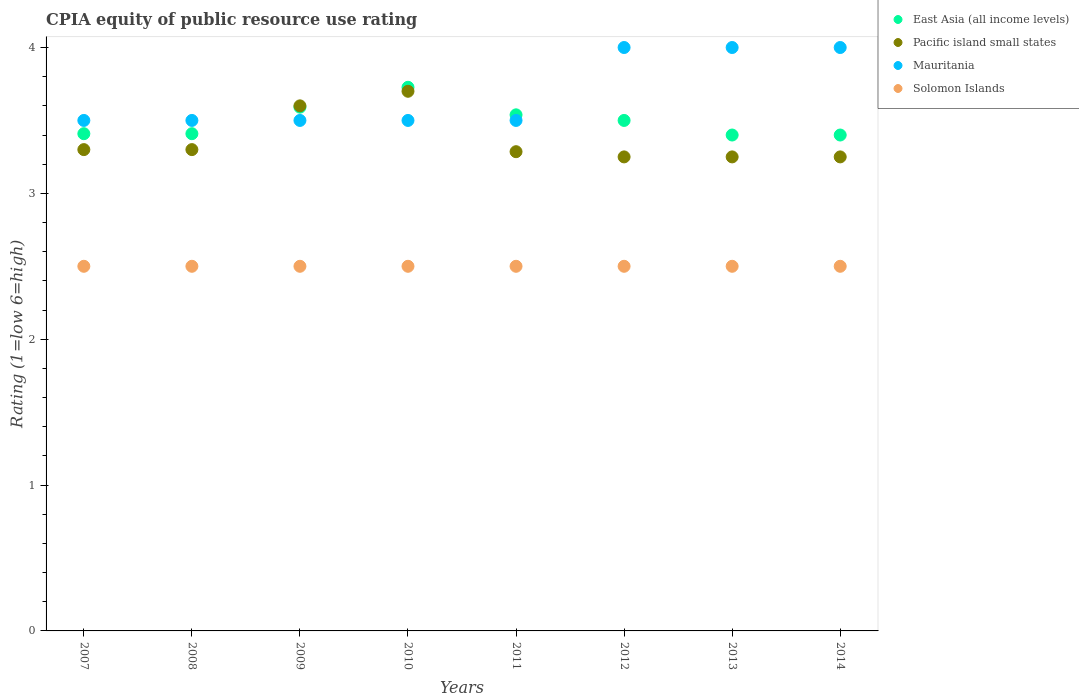Is the number of dotlines equal to the number of legend labels?
Keep it short and to the point. Yes. What is the CPIA rating in Pacific island small states in 2014?
Give a very brief answer. 3.25. Across all years, what is the minimum CPIA rating in Pacific island small states?
Provide a succinct answer. 3.25. In which year was the CPIA rating in Mauritania maximum?
Offer a terse response. 2012. What is the total CPIA rating in East Asia (all income levels) in the graph?
Provide a succinct answer. 27.97. What is the difference between the CPIA rating in Pacific island small states in 2012 and the CPIA rating in East Asia (all income levels) in 2009?
Offer a terse response. -0.34. What is the average CPIA rating in East Asia (all income levels) per year?
Keep it short and to the point. 3.5. In how many years, is the CPIA rating in East Asia (all income levels) greater than 2.8?
Provide a succinct answer. 8. What is the ratio of the CPIA rating in Solomon Islands in 2012 to that in 2013?
Provide a short and direct response. 1. Is the difference between the CPIA rating in Solomon Islands in 2009 and 2012 greater than the difference between the CPIA rating in Mauritania in 2009 and 2012?
Your answer should be compact. Yes. What is the difference between the highest and the second highest CPIA rating in Mauritania?
Give a very brief answer. 0. What is the difference between the highest and the lowest CPIA rating in East Asia (all income levels)?
Provide a succinct answer. 0.33. In how many years, is the CPIA rating in Solomon Islands greater than the average CPIA rating in Solomon Islands taken over all years?
Offer a terse response. 0. Is the sum of the CPIA rating in Solomon Islands in 2010 and 2012 greater than the maximum CPIA rating in Mauritania across all years?
Offer a very short reply. Yes. Is it the case that in every year, the sum of the CPIA rating in East Asia (all income levels) and CPIA rating in Pacific island small states  is greater than the sum of CPIA rating in Solomon Islands and CPIA rating in Mauritania?
Offer a very short reply. No. Is it the case that in every year, the sum of the CPIA rating in Solomon Islands and CPIA rating in Pacific island small states  is greater than the CPIA rating in East Asia (all income levels)?
Ensure brevity in your answer.  Yes. What is the difference between two consecutive major ticks on the Y-axis?
Provide a short and direct response. 1. Where does the legend appear in the graph?
Give a very brief answer. Top right. How many legend labels are there?
Provide a short and direct response. 4. What is the title of the graph?
Your answer should be very brief. CPIA equity of public resource use rating. Does "Senegal" appear as one of the legend labels in the graph?
Ensure brevity in your answer.  No. What is the Rating (1=low 6=high) of East Asia (all income levels) in 2007?
Give a very brief answer. 3.41. What is the Rating (1=low 6=high) in Pacific island small states in 2007?
Provide a succinct answer. 3.3. What is the Rating (1=low 6=high) of Mauritania in 2007?
Offer a very short reply. 3.5. What is the Rating (1=low 6=high) in Solomon Islands in 2007?
Provide a succinct answer. 2.5. What is the Rating (1=low 6=high) of East Asia (all income levels) in 2008?
Keep it short and to the point. 3.41. What is the Rating (1=low 6=high) in Mauritania in 2008?
Your response must be concise. 3.5. What is the Rating (1=low 6=high) in East Asia (all income levels) in 2009?
Offer a very short reply. 3.59. What is the Rating (1=low 6=high) of Pacific island small states in 2009?
Make the answer very short. 3.6. What is the Rating (1=low 6=high) of Solomon Islands in 2009?
Provide a short and direct response. 2.5. What is the Rating (1=low 6=high) of East Asia (all income levels) in 2010?
Offer a terse response. 3.73. What is the Rating (1=low 6=high) in Pacific island small states in 2010?
Offer a very short reply. 3.7. What is the Rating (1=low 6=high) in Solomon Islands in 2010?
Make the answer very short. 2.5. What is the Rating (1=low 6=high) in East Asia (all income levels) in 2011?
Offer a terse response. 3.54. What is the Rating (1=low 6=high) in Pacific island small states in 2011?
Provide a short and direct response. 3.29. What is the Rating (1=low 6=high) in East Asia (all income levels) in 2012?
Your response must be concise. 3.5. What is the Rating (1=low 6=high) of East Asia (all income levels) in 2013?
Make the answer very short. 3.4. What is the Rating (1=low 6=high) in Mauritania in 2013?
Give a very brief answer. 4. What is the Rating (1=low 6=high) of Solomon Islands in 2013?
Offer a very short reply. 2.5. What is the Rating (1=low 6=high) of East Asia (all income levels) in 2014?
Offer a very short reply. 3.4. Across all years, what is the maximum Rating (1=low 6=high) in East Asia (all income levels)?
Make the answer very short. 3.73. Across all years, what is the maximum Rating (1=low 6=high) of Solomon Islands?
Your answer should be compact. 2.5. Across all years, what is the minimum Rating (1=low 6=high) in East Asia (all income levels)?
Provide a short and direct response. 3.4. Across all years, what is the minimum Rating (1=low 6=high) of Solomon Islands?
Give a very brief answer. 2.5. What is the total Rating (1=low 6=high) of East Asia (all income levels) in the graph?
Offer a terse response. 27.97. What is the total Rating (1=low 6=high) in Pacific island small states in the graph?
Make the answer very short. 26.94. What is the total Rating (1=low 6=high) of Mauritania in the graph?
Provide a short and direct response. 29.5. What is the difference between the Rating (1=low 6=high) of East Asia (all income levels) in 2007 and that in 2008?
Your answer should be very brief. 0. What is the difference between the Rating (1=low 6=high) of Mauritania in 2007 and that in 2008?
Make the answer very short. 0. What is the difference between the Rating (1=low 6=high) of East Asia (all income levels) in 2007 and that in 2009?
Give a very brief answer. -0.18. What is the difference between the Rating (1=low 6=high) in Mauritania in 2007 and that in 2009?
Ensure brevity in your answer.  0. What is the difference between the Rating (1=low 6=high) in Solomon Islands in 2007 and that in 2009?
Provide a succinct answer. 0. What is the difference between the Rating (1=low 6=high) of East Asia (all income levels) in 2007 and that in 2010?
Your answer should be compact. -0.32. What is the difference between the Rating (1=low 6=high) in Pacific island small states in 2007 and that in 2010?
Keep it short and to the point. -0.4. What is the difference between the Rating (1=low 6=high) of East Asia (all income levels) in 2007 and that in 2011?
Provide a short and direct response. -0.13. What is the difference between the Rating (1=low 6=high) of Pacific island small states in 2007 and that in 2011?
Your response must be concise. 0.01. What is the difference between the Rating (1=low 6=high) of East Asia (all income levels) in 2007 and that in 2012?
Make the answer very short. -0.09. What is the difference between the Rating (1=low 6=high) of Pacific island small states in 2007 and that in 2012?
Provide a short and direct response. 0.05. What is the difference between the Rating (1=low 6=high) in Solomon Islands in 2007 and that in 2012?
Your answer should be compact. 0. What is the difference between the Rating (1=low 6=high) in East Asia (all income levels) in 2007 and that in 2013?
Provide a short and direct response. 0.01. What is the difference between the Rating (1=low 6=high) of Pacific island small states in 2007 and that in 2013?
Provide a succinct answer. 0.05. What is the difference between the Rating (1=low 6=high) in Solomon Islands in 2007 and that in 2013?
Your answer should be very brief. 0. What is the difference between the Rating (1=low 6=high) in East Asia (all income levels) in 2007 and that in 2014?
Your answer should be very brief. 0.01. What is the difference between the Rating (1=low 6=high) of East Asia (all income levels) in 2008 and that in 2009?
Provide a short and direct response. -0.18. What is the difference between the Rating (1=low 6=high) of Solomon Islands in 2008 and that in 2009?
Ensure brevity in your answer.  0. What is the difference between the Rating (1=low 6=high) of East Asia (all income levels) in 2008 and that in 2010?
Offer a terse response. -0.32. What is the difference between the Rating (1=low 6=high) of Pacific island small states in 2008 and that in 2010?
Your response must be concise. -0.4. What is the difference between the Rating (1=low 6=high) of Solomon Islands in 2008 and that in 2010?
Provide a short and direct response. 0. What is the difference between the Rating (1=low 6=high) of East Asia (all income levels) in 2008 and that in 2011?
Provide a short and direct response. -0.13. What is the difference between the Rating (1=low 6=high) in Pacific island small states in 2008 and that in 2011?
Provide a succinct answer. 0.01. What is the difference between the Rating (1=low 6=high) in East Asia (all income levels) in 2008 and that in 2012?
Ensure brevity in your answer.  -0.09. What is the difference between the Rating (1=low 6=high) in Pacific island small states in 2008 and that in 2012?
Keep it short and to the point. 0.05. What is the difference between the Rating (1=low 6=high) of East Asia (all income levels) in 2008 and that in 2013?
Keep it short and to the point. 0.01. What is the difference between the Rating (1=low 6=high) in Pacific island small states in 2008 and that in 2013?
Ensure brevity in your answer.  0.05. What is the difference between the Rating (1=low 6=high) of East Asia (all income levels) in 2008 and that in 2014?
Provide a short and direct response. 0.01. What is the difference between the Rating (1=low 6=high) in Mauritania in 2008 and that in 2014?
Your answer should be very brief. -0.5. What is the difference between the Rating (1=low 6=high) of East Asia (all income levels) in 2009 and that in 2010?
Provide a succinct answer. -0.14. What is the difference between the Rating (1=low 6=high) of Mauritania in 2009 and that in 2010?
Provide a short and direct response. 0. What is the difference between the Rating (1=low 6=high) of Solomon Islands in 2009 and that in 2010?
Your answer should be very brief. 0. What is the difference between the Rating (1=low 6=high) in East Asia (all income levels) in 2009 and that in 2011?
Your answer should be very brief. 0.05. What is the difference between the Rating (1=low 6=high) of Pacific island small states in 2009 and that in 2011?
Your response must be concise. 0.31. What is the difference between the Rating (1=low 6=high) in East Asia (all income levels) in 2009 and that in 2012?
Give a very brief answer. 0.09. What is the difference between the Rating (1=low 6=high) of Solomon Islands in 2009 and that in 2012?
Provide a short and direct response. 0. What is the difference between the Rating (1=low 6=high) in East Asia (all income levels) in 2009 and that in 2013?
Offer a terse response. 0.19. What is the difference between the Rating (1=low 6=high) of Mauritania in 2009 and that in 2013?
Ensure brevity in your answer.  -0.5. What is the difference between the Rating (1=low 6=high) of Solomon Islands in 2009 and that in 2013?
Make the answer very short. 0. What is the difference between the Rating (1=low 6=high) in East Asia (all income levels) in 2009 and that in 2014?
Your answer should be very brief. 0.19. What is the difference between the Rating (1=low 6=high) of Pacific island small states in 2009 and that in 2014?
Ensure brevity in your answer.  0.35. What is the difference between the Rating (1=low 6=high) of Mauritania in 2009 and that in 2014?
Ensure brevity in your answer.  -0.5. What is the difference between the Rating (1=low 6=high) in East Asia (all income levels) in 2010 and that in 2011?
Your answer should be very brief. 0.19. What is the difference between the Rating (1=low 6=high) in Pacific island small states in 2010 and that in 2011?
Provide a short and direct response. 0.41. What is the difference between the Rating (1=low 6=high) in Mauritania in 2010 and that in 2011?
Make the answer very short. 0. What is the difference between the Rating (1=low 6=high) in East Asia (all income levels) in 2010 and that in 2012?
Give a very brief answer. 0.23. What is the difference between the Rating (1=low 6=high) in Pacific island small states in 2010 and that in 2012?
Make the answer very short. 0.45. What is the difference between the Rating (1=low 6=high) in Mauritania in 2010 and that in 2012?
Ensure brevity in your answer.  -0.5. What is the difference between the Rating (1=low 6=high) in East Asia (all income levels) in 2010 and that in 2013?
Offer a terse response. 0.33. What is the difference between the Rating (1=low 6=high) of Pacific island small states in 2010 and that in 2013?
Offer a terse response. 0.45. What is the difference between the Rating (1=low 6=high) of Solomon Islands in 2010 and that in 2013?
Provide a short and direct response. 0. What is the difference between the Rating (1=low 6=high) of East Asia (all income levels) in 2010 and that in 2014?
Keep it short and to the point. 0.33. What is the difference between the Rating (1=low 6=high) in Pacific island small states in 2010 and that in 2014?
Ensure brevity in your answer.  0.45. What is the difference between the Rating (1=low 6=high) of East Asia (all income levels) in 2011 and that in 2012?
Give a very brief answer. 0.04. What is the difference between the Rating (1=low 6=high) in Pacific island small states in 2011 and that in 2012?
Offer a very short reply. 0.04. What is the difference between the Rating (1=low 6=high) in East Asia (all income levels) in 2011 and that in 2013?
Keep it short and to the point. 0.14. What is the difference between the Rating (1=low 6=high) of Pacific island small states in 2011 and that in 2013?
Your response must be concise. 0.04. What is the difference between the Rating (1=low 6=high) in East Asia (all income levels) in 2011 and that in 2014?
Your answer should be compact. 0.14. What is the difference between the Rating (1=low 6=high) in Pacific island small states in 2011 and that in 2014?
Make the answer very short. 0.04. What is the difference between the Rating (1=low 6=high) in Solomon Islands in 2011 and that in 2014?
Your answer should be compact. 0. What is the difference between the Rating (1=low 6=high) of Mauritania in 2012 and that in 2013?
Make the answer very short. 0. What is the difference between the Rating (1=low 6=high) in Pacific island small states in 2012 and that in 2014?
Ensure brevity in your answer.  0. What is the difference between the Rating (1=low 6=high) of Mauritania in 2012 and that in 2014?
Your answer should be compact. 0. What is the difference between the Rating (1=low 6=high) of East Asia (all income levels) in 2013 and that in 2014?
Your response must be concise. 0. What is the difference between the Rating (1=low 6=high) of Mauritania in 2013 and that in 2014?
Give a very brief answer. 0. What is the difference between the Rating (1=low 6=high) in East Asia (all income levels) in 2007 and the Rating (1=low 6=high) in Pacific island small states in 2008?
Give a very brief answer. 0.11. What is the difference between the Rating (1=low 6=high) in East Asia (all income levels) in 2007 and the Rating (1=low 6=high) in Mauritania in 2008?
Offer a very short reply. -0.09. What is the difference between the Rating (1=low 6=high) in East Asia (all income levels) in 2007 and the Rating (1=low 6=high) in Solomon Islands in 2008?
Ensure brevity in your answer.  0.91. What is the difference between the Rating (1=low 6=high) in Pacific island small states in 2007 and the Rating (1=low 6=high) in Mauritania in 2008?
Ensure brevity in your answer.  -0.2. What is the difference between the Rating (1=low 6=high) of Pacific island small states in 2007 and the Rating (1=low 6=high) of Solomon Islands in 2008?
Make the answer very short. 0.8. What is the difference between the Rating (1=low 6=high) of Mauritania in 2007 and the Rating (1=low 6=high) of Solomon Islands in 2008?
Provide a short and direct response. 1. What is the difference between the Rating (1=low 6=high) of East Asia (all income levels) in 2007 and the Rating (1=low 6=high) of Pacific island small states in 2009?
Provide a short and direct response. -0.19. What is the difference between the Rating (1=low 6=high) of East Asia (all income levels) in 2007 and the Rating (1=low 6=high) of Mauritania in 2009?
Ensure brevity in your answer.  -0.09. What is the difference between the Rating (1=low 6=high) of East Asia (all income levels) in 2007 and the Rating (1=low 6=high) of Solomon Islands in 2009?
Your answer should be compact. 0.91. What is the difference between the Rating (1=low 6=high) of Pacific island small states in 2007 and the Rating (1=low 6=high) of Mauritania in 2009?
Keep it short and to the point. -0.2. What is the difference between the Rating (1=low 6=high) of Pacific island small states in 2007 and the Rating (1=low 6=high) of Solomon Islands in 2009?
Give a very brief answer. 0.8. What is the difference between the Rating (1=low 6=high) of East Asia (all income levels) in 2007 and the Rating (1=low 6=high) of Pacific island small states in 2010?
Your response must be concise. -0.29. What is the difference between the Rating (1=low 6=high) of East Asia (all income levels) in 2007 and the Rating (1=low 6=high) of Mauritania in 2010?
Ensure brevity in your answer.  -0.09. What is the difference between the Rating (1=low 6=high) in East Asia (all income levels) in 2007 and the Rating (1=low 6=high) in Solomon Islands in 2010?
Offer a very short reply. 0.91. What is the difference between the Rating (1=low 6=high) of Pacific island small states in 2007 and the Rating (1=low 6=high) of Solomon Islands in 2010?
Offer a terse response. 0.8. What is the difference between the Rating (1=low 6=high) of Mauritania in 2007 and the Rating (1=low 6=high) of Solomon Islands in 2010?
Give a very brief answer. 1. What is the difference between the Rating (1=low 6=high) in East Asia (all income levels) in 2007 and the Rating (1=low 6=high) in Pacific island small states in 2011?
Offer a terse response. 0.12. What is the difference between the Rating (1=low 6=high) in East Asia (all income levels) in 2007 and the Rating (1=low 6=high) in Mauritania in 2011?
Your answer should be compact. -0.09. What is the difference between the Rating (1=low 6=high) in Pacific island small states in 2007 and the Rating (1=low 6=high) in Mauritania in 2011?
Keep it short and to the point. -0.2. What is the difference between the Rating (1=low 6=high) in Pacific island small states in 2007 and the Rating (1=low 6=high) in Solomon Islands in 2011?
Make the answer very short. 0.8. What is the difference between the Rating (1=low 6=high) in East Asia (all income levels) in 2007 and the Rating (1=low 6=high) in Pacific island small states in 2012?
Your answer should be very brief. 0.16. What is the difference between the Rating (1=low 6=high) of East Asia (all income levels) in 2007 and the Rating (1=low 6=high) of Mauritania in 2012?
Your answer should be very brief. -0.59. What is the difference between the Rating (1=low 6=high) of Pacific island small states in 2007 and the Rating (1=low 6=high) of Mauritania in 2012?
Your answer should be very brief. -0.7. What is the difference between the Rating (1=low 6=high) of East Asia (all income levels) in 2007 and the Rating (1=low 6=high) of Pacific island small states in 2013?
Your response must be concise. 0.16. What is the difference between the Rating (1=low 6=high) of East Asia (all income levels) in 2007 and the Rating (1=low 6=high) of Mauritania in 2013?
Your answer should be compact. -0.59. What is the difference between the Rating (1=low 6=high) of East Asia (all income levels) in 2007 and the Rating (1=low 6=high) of Solomon Islands in 2013?
Your response must be concise. 0.91. What is the difference between the Rating (1=low 6=high) of Pacific island small states in 2007 and the Rating (1=low 6=high) of Mauritania in 2013?
Your answer should be very brief. -0.7. What is the difference between the Rating (1=low 6=high) in East Asia (all income levels) in 2007 and the Rating (1=low 6=high) in Pacific island small states in 2014?
Your answer should be compact. 0.16. What is the difference between the Rating (1=low 6=high) of East Asia (all income levels) in 2007 and the Rating (1=low 6=high) of Mauritania in 2014?
Your answer should be very brief. -0.59. What is the difference between the Rating (1=low 6=high) of Pacific island small states in 2007 and the Rating (1=low 6=high) of Solomon Islands in 2014?
Keep it short and to the point. 0.8. What is the difference between the Rating (1=low 6=high) of Mauritania in 2007 and the Rating (1=low 6=high) of Solomon Islands in 2014?
Your answer should be compact. 1. What is the difference between the Rating (1=low 6=high) in East Asia (all income levels) in 2008 and the Rating (1=low 6=high) in Pacific island small states in 2009?
Make the answer very short. -0.19. What is the difference between the Rating (1=low 6=high) in East Asia (all income levels) in 2008 and the Rating (1=low 6=high) in Mauritania in 2009?
Ensure brevity in your answer.  -0.09. What is the difference between the Rating (1=low 6=high) of East Asia (all income levels) in 2008 and the Rating (1=low 6=high) of Solomon Islands in 2009?
Give a very brief answer. 0.91. What is the difference between the Rating (1=low 6=high) of Pacific island small states in 2008 and the Rating (1=low 6=high) of Solomon Islands in 2009?
Make the answer very short. 0.8. What is the difference between the Rating (1=low 6=high) of East Asia (all income levels) in 2008 and the Rating (1=low 6=high) of Pacific island small states in 2010?
Your answer should be compact. -0.29. What is the difference between the Rating (1=low 6=high) in East Asia (all income levels) in 2008 and the Rating (1=low 6=high) in Mauritania in 2010?
Offer a terse response. -0.09. What is the difference between the Rating (1=low 6=high) in East Asia (all income levels) in 2008 and the Rating (1=low 6=high) in Solomon Islands in 2010?
Your response must be concise. 0.91. What is the difference between the Rating (1=low 6=high) of Mauritania in 2008 and the Rating (1=low 6=high) of Solomon Islands in 2010?
Keep it short and to the point. 1. What is the difference between the Rating (1=low 6=high) of East Asia (all income levels) in 2008 and the Rating (1=low 6=high) of Pacific island small states in 2011?
Offer a very short reply. 0.12. What is the difference between the Rating (1=low 6=high) in East Asia (all income levels) in 2008 and the Rating (1=low 6=high) in Mauritania in 2011?
Your response must be concise. -0.09. What is the difference between the Rating (1=low 6=high) in Pacific island small states in 2008 and the Rating (1=low 6=high) in Mauritania in 2011?
Provide a short and direct response. -0.2. What is the difference between the Rating (1=low 6=high) of Pacific island small states in 2008 and the Rating (1=low 6=high) of Solomon Islands in 2011?
Make the answer very short. 0.8. What is the difference between the Rating (1=low 6=high) of East Asia (all income levels) in 2008 and the Rating (1=low 6=high) of Pacific island small states in 2012?
Offer a very short reply. 0.16. What is the difference between the Rating (1=low 6=high) in East Asia (all income levels) in 2008 and the Rating (1=low 6=high) in Mauritania in 2012?
Provide a succinct answer. -0.59. What is the difference between the Rating (1=low 6=high) in Pacific island small states in 2008 and the Rating (1=low 6=high) in Solomon Islands in 2012?
Ensure brevity in your answer.  0.8. What is the difference between the Rating (1=low 6=high) of East Asia (all income levels) in 2008 and the Rating (1=low 6=high) of Pacific island small states in 2013?
Your response must be concise. 0.16. What is the difference between the Rating (1=low 6=high) in East Asia (all income levels) in 2008 and the Rating (1=low 6=high) in Mauritania in 2013?
Your answer should be very brief. -0.59. What is the difference between the Rating (1=low 6=high) in Pacific island small states in 2008 and the Rating (1=low 6=high) in Mauritania in 2013?
Keep it short and to the point. -0.7. What is the difference between the Rating (1=low 6=high) of Pacific island small states in 2008 and the Rating (1=low 6=high) of Solomon Islands in 2013?
Your answer should be very brief. 0.8. What is the difference between the Rating (1=low 6=high) in East Asia (all income levels) in 2008 and the Rating (1=low 6=high) in Pacific island small states in 2014?
Provide a short and direct response. 0.16. What is the difference between the Rating (1=low 6=high) in East Asia (all income levels) in 2008 and the Rating (1=low 6=high) in Mauritania in 2014?
Make the answer very short. -0.59. What is the difference between the Rating (1=low 6=high) in Mauritania in 2008 and the Rating (1=low 6=high) in Solomon Islands in 2014?
Your answer should be very brief. 1. What is the difference between the Rating (1=low 6=high) in East Asia (all income levels) in 2009 and the Rating (1=low 6=high) in Pacific island small states in 2010?
Ensure brevity in your answer.  -0.11. What is the difference between the Rating (1=low 6=high) of East Asia (all income levels) in 2009 and the Rating (1=low 6=high) of Mauritania in 2010?
Make the answer very short. 0.09. What is the difference between the Rating (1=low 6=high) of Mauritania in 2009 and the Rating (1=low 6=high) of Solomon Islands in 2010?
Keep it short and to the point. 1. What is the difference between the Rating (1=low 6=high) in East Asia (all income levels) in 2009 and the Rating (1=low 6=high) in Pacific island small states in 2011?
Keep it short and to the point. 0.31. What is the difference between the Rating (1=low 6=high) of East Asia (all income levels) in 2009 and the Rating (1=low 6=high) of Mauritania in 2011?
Your answer should be very brief. 0.09. What is the difference between the Rating (1=low 6=high) of East Asia (all income levels) in 2009 and the Rating (1=low 6=high) of Solomon Islands in 2011?
Make the answer very short. 1.09. What is the difference between the Rating (1=low 6=high) in Mauritania in 2009 and the Rating (1=low 6=high) in Solomon Islands in 2011?
Offer a terse response. 1. What is the difference between the Rating (1=low 6=high) in East Asia (all income levels) in 2009 and the Rating (1=low 6=high) in Pacific island small states in 2012?
Offer a terse response. 0.34. What is the difference between the Rating (1=low 6=high) in East Asia (all income levels) in 2009 and the Rating (1=low 6=high) in Mauritania in 2012?
Your response must be concise. -0.41. What is the difference between the Rating (1=low 6=high) of Pacific island small states in 2009 and the Rating (1=low 6=high) of Mauritania in 2012?
Offer a terse response. -0.4. What is the difference between the Rating (1=low 6=high) in Mauritania in 2009 and the Rating (1=low 6=high) in Solomon Islands in 2012?
Keep it short and to the point. 1. What is the difference between the Rating (1=low 6=high) in East Asia (all income levels) in 2009 and the Rating (1=low 6=high) in Pacific island small states in 2013?
Your answer should be compact. 0.34. What is the difference between the Rating (1=low 6=high) in East Asia (all income levels) in 2009 and the Rating (1=low 6=high) in Mauritania in 2013?
Your response must be concise. -0.41. What is the difference between the Rating (1=low 6=high) of Pacific island small states in 2009 and the Rating (1=low 6=high) of Solomon Islands in 2013?
Provide a succinct answer. 1.1. What is the difference between the Rating (1=low 6=high) in East Asia (all income levels) in 2009 and the Rating (1=low 6=high) in Pacific island small states in 2014?
Your answer should be very brief. 0.34. What is the difference between the Rating (1=low 6=high) in East Asia (all income levels) in 2009 and the Rating (1=low 6=high) in Mauritania in 2014?
Provide a short and direct response. -0.41. What is the difference between the Rating (1=low 6=high) of Pacific island small states in 2009 and the Rating (1=low 6=high) of Mauritania in 2014?
Offer a terse response. -0.4. What is the difference between the Rating (1=low 6=high) in Pacific island small states in 2009 and the Rating (1=low 6=high) in Solomon Islands in 2014?
Ensure brevity in your answer.  1.1. What is the difference between the Rating (1=low 6=high) in East Asia (all income levels) in 2010 and the Rating (1=low 6=high) in Pacific island small states in 2011?
Offer a very short reply. 0.44. What is the difference between the Rating (1=low 6=high) of East Asia (all income levels) in 2010 and the Rating (1=low 6=high) of Mauritania in 2011?
Offer a terse response. 0.23. What is the difference between the Rating (1=low 6=high) in East Asia (all income levels) in 2010 and the Rating (1=low 6=high) in Solomon Islands in 2011?
Provide a succinct answer. 1.23. What is the difference between the Rating (1=low 6=high) of Mauritania in 2010 and the Rating (1=low 6=high) of Solomon Islands in 2011?
Ensure brevity in your answer.  1. What is the difference between the Rating (1=low 6=high) in East Asia (all income levels) in 2010 and the Rating (1=low 6=high) in Pacific island small states in 2012?
Give a very brief answer. 0.48. What is the difference between the Rating (1=low 6=high) of East Asia (all income levels) in 2010 and the Rating (1=low 6=high) of Mauritania in 2012?
Provide a succinct answer. -0.27. What is the difference between the Rating (1=low 6=high) of East Asia (all income levels) in 2010 and the Rating (1=low 6=high) of Solomon Islands in 2012?
Give a very brief answer. 1.23. What is the difference between the Rating (1=low 6=high) in East Asia (all income levels) in 2010 and the Rating (1=low 6=high) in Pacific island small states in 2013?
Your answer should be compact. 0.48. What is the difference between the Rating (1=low 6=high) in East Asia (all income levels) in 2010 and the Rating (1=low 6=high) in Mauritania in 2013?
Provide a short and direct response. -0.27. What is the difference between the Rating (1=low 6=high) in East Asia (all income levels) in 2010 and the Rating (1=low 6=high) in Solomon Islands in 2013?
Your answer should be compact. 1.23. What is the difference between the Rating (1=low 6=high) of Pacific island small states in 2010 and the Rating (1=low 6=high) of Mauritania in 2013?
Ensure brevity in your answer.  -0.3. What is the difference between the Rating (1=low 6=high) in East Asia (all income levels) in 2010 and the Rating (1=low 6=high) in Pacific island small states in 2014?
Give a very brief answer. 0.48. What is the difference between the Rating (1=low 6=high) in East Asia (all income levels) in 2010 and the Rating (1=low 6=high) in Mauritania in 2014?
Offer a terse response. -0.27. What is the difference between the Rating (1=low 6=high) of East Asia (all income levels) in 2010 and the Rating (1=low 6=high) of Solomon Islands in 2014?
Provide a short and direct response. 1.23. What is the difference between the Rating (1=low 6=high) of Pacific island small states in 2010 and the Rating (1=low 6=high) of Mauritania in 2014?
Offer a very short reply. -0.3. What is the difference between the Rating (1=low 6=high) in Pacific island small states in 2010 and the Rating (1=low 6=high) in Solomon Islands in 2014?
Keep it short and to the point. 1.2. What is the difference between the Rating (1=low 6=high) of Mauritania in 2010 and the Rating (1=low 6=high) of Solomon Islands in 2014?
Offer a very short reply. 1. What is the difference between the Rating (1=low 6=high) in East Asia (all income levels) in 2011 and the Rating (1=low 6=high) in Pacific island small states in 2012?
Give a very brief answer. 0.29. What is the difference between the Rating (1=low 6=high) in East Asia (all income levels) in 2011 and the Rating (1=low 6=high) in Mauritania in 2012?
Offer a terse response. -0.46. What is the difference between the Rating (1=low 6=high) of East Asia (all income levels) in 2011 and the Rating (1=low 6=high) of Solomon Islands in 2012?
Keep it short and to the point. 1.04. What is the difference between the Rating (1=low 6=high) of Pacific island small states in 2011 and the Rating (1=low 6=high) of Mauritania in 2012?
Offer a terse response. -0.71. What is the difference between the Rating (1=low 6=high) of Pacific island small states in 2011 and the Rating (1=low 6=high) of Solomon Islands in 2012?
Keep it short and to the point. 0.79. What is the difference between the Rating (1=low 6=high) in Mauritania in 2011 and the Rating (1=low 6=high) in Solomon Islands in 2012?
Offer a terse response. 1. What is the difference between the Rating (1=low 6=high) of East Asia (all income levels) in 2011 and the Rating (1=low 6=high) of Pacific island small states in 2013?
Give a very brief answer. 0.29. What is the difference between the Rating (1=low 6=high) of East Asia (all income levels) in 2011 and the Rating (1=low 6=high) of Mauritania in 2013?
Make the answer very short. -0.46. What is the difference between the Rating (1=low 6=high) in Pacific island small states in 2011 and the Rating (1=low 6=high) in Mauritania in 2013?
Provide a succinct answer. -0.71. What is the difference between the Rating (1=low 6=high) in Pacific island small states in 2011 and the Rating (1=low 6=high) in Solomon Islands in 2013?
Ensure brevity in your answer.  0.79. What is the difference between the Rating (1=low 6=high) in Mauritania in 2011 and the Rating (1=low 6=high) in Solomon Islands in 2013?
Ensure brevity in your answer.  1. What is the difference between the Rating (1=low 6=high) in East Asia (all income levels) in 2011 and the Rating (1=low 6=high) in Pacific island small states in 2014?
Your answer should be very brief. 0.29. What is the difference between the Rating (1=low 6=high) of East Asia (all income levels) in 2011 and the Rating (1=low 6=high) of Mauritania in 2014?
Offer a terse response. -0.46. What is the difference between the Rating (1=low 6=high) of East Asia (all income levels) in 2011 and the Rating (1=low 6=high) of Solomon Islands in 2014?
Keep it short and to the point. 1.04. What is the difference between the Rating (1=low 6=high) of Pacific island small states in 2011 and the Rating (1=low 6=high) of Mauritania in 2014?
Offer a very short reply. -0.71. What is the difference between the Rating (1=low 6=high) of Pacific island small states in 2011 and the Rating (1=low 6=high) of Solomon Islands in 2014?
Make the answer very short. 0.79. What is the difference between the Rating (1=low 6=high) in Mauritania in 2011 and the Rating (1=low 6=high) in Solomon Islands in 2014?
Your response must be concise. 1. What is the difference between the Rating (1=low 6=high) of Pacific island small states in 2012 and the Rating (1=low 6=high) of Mauritania in 2013?
Keep it short and to the point. -0.75. What is the difference between the Rating (1=low 6=high) of Pacific island small states in 2012 and the Rating (1=low 6=high) of Solomon Islands in 2013?
Provide a succinct answer. 0.75. What is the difference between the Rating (1=low 6=high) in Mauritania in 2012 and the Rating (1=low 6=high) in Solomon Islands in 2013?
Make the answer very short. 1.5. What is the difference between the Rating (1=low 6=high) of Pacific island small states in 2012 and the Rating (1=low 6=high) of Mauritania in 2014?
Provide a short and direct response. -0.75. What is the difference between the Rating (1=low 6=high) of Pacific island small states in 2012 and the Rating (1=low 6=high) of Solomon Islands in 2014?
Keep it short and to the point. 0.75. What is the difference between the Rating (1=low 6=high) in Mauritania in 2012 and the Rating (1=low 6=high) in Solomon Islands in 2014?
Provide a short and direct response. 1.5. What is the difference between the Rating (1=low 6=high) in East Asia (all income levels) in 2013 and the Rating (1=low 6=high) in Mauritania in 2014?
Make the answer very short. -0.6. What is the difference between the Rating (1=low 6=high) of East Asia (all income levels) in 2013 and the Rating (1=low 6=high) of Solomon Islands in 2014?
Your response must be concise. 0.9. What is the difference between the Rating (1=low 6=high) of Pacific island small states in 2013 and the Rating (1=low 6=high) of Mauritania in 2014?
Offer a very short reply. -0.75. What is the difference between the Rating (1=low 6=high) of Mauritania in 2013 and the Rating (1=low 6=high) of Solomon Islands in 2014?
Offer a very short reply. 1.5. What is the average Rating (1=low 6=high) in East Asia (all income levels) per year?
Provide a short and direct response. 3.5. What is the average Rating (1=low 6=high) in Pacific island small states per year?
Ensure brevity in your answer.  3.37. What is the average Rating (1=low 6=high) of Mauritania per year?
Give a very brief answer. 3.69. What is the average Rating (1=low 6=high) in Solomon Islands per year?
Your answer should be compact. 2.5. In the year 2007, what is the difference between the Rating (1=low 6=high) in East Asia (all income levels) and Rating (1=low 6=high) in Pacific island small states?
Give a very brief answer. 0.11. In the year 2007, what is the difference between the Rating (1=low 6=high) in East Asia (all income levels) and Rating (1=low 6=high) in Mauritania?
Keep it short and to the point. -0.09. In the year 2008, what is the difference between the Rating (1=low 6=high) of East Asia (all income levels) and Rating (1=low 6=high) of Pacific island small states?
Offer a very short reply. 0.11. In the year 2008, what is the difference between the Rating (1=low 6=high) of East Asia (all income levels) and Rating (1=low 6=high) of Mauritania?
Make the answer very short. -0.09. In the year 2008, what is the difference between the Rating (1=low 6=high) of East Asia (all income levels) and Rating (1=low 6=high) of Solomon Islands?
Provide a short and direct response. 0.91. In the year 2008, what is the difference between the Rating (1=low 6=high) in Pacific island small states and Rating (1=low 6=high) in Mauritania?
Give a very brief answer. -0.2. In the year 2009, what is the difference between the Rating (1=low 6=high) in East Asia (all income levels) and Rating (1=low 6=high) in Pacific island small states?
Give a very brief answer. -0.01. In the year 2009, what is the difference between the Rating (1=low 6=high) in East Asia (all income levels) and Rating (1=low 6=high) in Mauritania?
Give a very brief answer. 0.09. In the year 2009, what is the difference between the Rating (1=low 6=high) of East Asia (all income levels) and Rating (1=low 6=high) of Solomon Islands?
Your answer should be very brief. 1.09. In the year 2009, what is the difference between the Rating (1=low 6=high) in Pacific island small states and Rating (1=low 6=high) in Solomon Islands?
Make the answer very short. 1.1. In the year 2010, what is the difference between the Rating (1=low 6=high) in East Asia (all income levels) and Rating (1=low 6=high) in Pacific island small states?
Your answer should be very brief. 0.03. In the year 2010, what is the difference between the Rating (1=low 6=high) in East Asia (all income levels) and Rating (1=low 6=high) in Mauritania?
Offer a terse response. 0.23. In the year 2010, what is the difference between the Rating (1=low 6=high) of East Asia (all income levels) and Rating (1=low 6=high) of Solomon Islands?
Provide a succinct answer. 1.23. In the year 2011, what is the difference between the Rating (1=low 6=high) in East Asia (all income levels) and Rating (1=low 6=high) in Pacific island small states?
Provide a short and direct response. 0.25. In the year 2011, what is the difference between the Rating (1=low 6=high) in East Asia (all income levels) and Rating (1=low 6=high) in Mauritania?
Your answer should be compact. 0.04. In the year 2011, what is the difference between the Rating (1=low 6=high) in Pacific island small states and Rating (1=low 6=high) in Mauritania?
Your answer should be compact. -0.21. In the year 2011, what is the difference between the Rating (1=low 6=high) in Pacific island small states and Rating (1=low 6=high) in Solomon Islands?
Your answer should be very brief. 0.79. In the year 2012, what is the difference between the Rating (1=low 6=high) in East Asia (all income levels) and Rating (1=low 6=high) in Solomon Islands?
Your response must be concise. 1. In the year 2012, what is the difference between the Rating (1=low 6=high) of Pacific island small states and Rating (1=low 6=high) of Mauritania?
Offer a very short reply. -0.75. In the year 2012, what is the difference between the Rating (1=low 6=high) in Mauritania and Rating (1=low 6=high) in Solomon Islands?
Your response must be concise. 1.5. In the year 2013, what is the difference between the Rating (1=low 6=high) in East Asia (all income levels) and Rating (1=low 6=high) in Pacific island small states?
Your answer should be very brief. 0.15. In the year 2013, what is the difference between the Rating (1=low 6=high) of East Asia (all income levels) and Rating (1=low 6=high) of Mauritania?
Provide a short and direct response. -0.6. In the year 2013, what is the difference between the Rating (1=low 6=high) of Pacific island small states and Rating (1=low 6=high) of Mauritania?
Give a very brief answer. -0.75. In the year 2013, what is the difference between the Rating (1=low 6=high) of Pacific island small states and Rating (1=low 6=high) of Solomon Islands?
Your answer should be compact. 0.75. In the year 2013, what is the difference between the Rating (1=low 6=high) in Mauritania and Rating (1=low 6=high) in Solomon Islands?
Offer a very short reply. 1.5. In the year 2014, what is the difference between the Rating (1=low 6=high) in Pacific island small states and Rating (1=low 6=high) in Mauritania?
Your response must be concise. -0.75. What is the ratio of the Rating (1=low 6=high) in East Asia (all income levels) in 2007 to that in 2008?
Give a very brief answer. 1. What is the ratio of the Rating (1=low 6=high) of Mauritania in 2007 to that in 2008?
Provide a short and direct response. 1. What is the ratio of the Rating (1=low 6=high) in Solomon Islands in 2007 to that in 2008?
Offer a very short reply. 1. What is the ratio of the Rating (1=low 6=high) of East Asia (all income levels) in 2007 to that in 2009?
Provide a short and direct response. 0.95. What is the ratio of the Rating (1=low 6=high) of Mauritania in 2007 to that in 2009?
Your answer should be very brief. 1. What is the ratio of the Rating (1=low 6=high) in Solomon Islands in 2007 to that in 2009?
Give a very brief answer. 1. What is the ratio of the Rating (1=low 6=high) in East Asia (all income levels) in 2007 to that in 2010?
Offer a terse response. 0.91. What is the ratio of the Rating (1=low 6=high) of Pacific island small states in 2007 to that in 2010?
Make the answer very short. 0.89. What is the ratio of the Rating (1=low 6=high) in East Asia (all income levels) in 2007 to that in 2011?
Your answer should be compact. 0.96. What is the ratio of the Rating (1=low 6=high) of Pacific island small states in 2007 to that in 2012?
Offer a terse response. 1.02. What is the ratio of the Rating (1=low 6=high) in Solomon Islands in 2007 to that in 2012?
Give a very brief answer. 1. What is the ratio of the Rating (1=low 6=high) of East Asia (all income levels) in 2007 to that in 2013?
Your answer should be compact. 1. What is the ratio of the Rating (1=low 6=high) in Pacific island small states in 2007 to that in 2013?
Give a very brief answer. 1.02. What is the ratio of the Rating (1=low 6=high) in Mauritania in 2007 to that in 2013?
Give a very brief answer. 0.88. What is the ratio of the Rating (1=low 6=high) of Solomon Islands in 2007 to that in 2013?
Ensure brevity in your answer.  1. What is the ratio of the Rating (1=low 6=high) of East Asia (all income levels) in 2007 to that in 2014?
Make the answer very short. 1. What is the ratio of the Rating (1=low 6=high) of Pacific island small states in 2007 to that in 2014?
Keep it short and to the point. 1.02. What is the ratio of the Rating (1=low 6=high) in Mauritania in 2007 to that in 2014?
Your answer should be very brief. 0.88. What is the ratio of the Rating (1=low 6=high) in Solomon Islands in 2007 to that in 2014?
Provide a succinct answer. 1. What is the ratio of the Rating (1=low 6=high) of East Asia (all income levels) in 2008 to that in 2009?
Keep it short and to the point. 0.95. What is the ratio of the Rating (1=low 6=high) in Pacific island small states in 2008 to that in 2009?
Provide a succinct answer. 0.92. What is the ratio of the Rating (1=low 6=high) in Solomon Islands in 2008 to that in 2009?
Your answer should be very brief. 1. What is the ratio of the Rating (1=low 6=high) in East Asia (all income levels) in 2008 to that in 2010?
Your response must be concise. 0.91. What is the ratio of the Rating (1=low 6=high) in Pacific island small states in 2008 to that in 2010?
Your answer should be compact. 0.89. What is the ratio of the Rating (1=low 6=high) in East Asia (all income levels) in 2008 to that in 2011?
Provide a short and direct response. 0.96. What is the ratio of the Rating (1=low 6=high) in Mauritania in 2008 to that in 2011?
Provide a short and direct response. 1. What is the ratio of the Rating (1=low 6=high) in Solomon Islands in 2008 to that in 2011?
Give a very brief answer. 1. What is the ratio of the Rating (1=low 6=high) in Pacific island small states in 2008 to that in 2012?
Ensure brevity in your answer.  1.02. What is the ratio of the Rating (1=low 6=high) of East Asia (all income levels) in 2008 to that in 2013?
Give a very brief answer. 1. What is the ratio of the Rating (1=low 6=high) in Pacific island small states in 2008 to that in 2013?
Your answer should be very brief. 1.02. What is the ratio of the Rating (1=low 6=high) in Pacific island small states in 2008 to that in 2014?
Give a very brief answer. 1.02. What is the ratio of the Rating (1=low 6=high) in Mauritania in 2008 to that in 2014?
Your response must be concise. 0.88. What is the ratio of the Rating (1=low 6=high) in East Asia (all income levels) in 2009 to that in 2010?
Keep it short and to the point. 0.96. What is the ratio of the Rating (1=low 6=high) of East Asia (all income levels) in 2009 to that in 2011?
Offer a terse response. 1.01. What is the ratio of the Rating (1=low 6=high) of Pacific island small states in 2009 to that in 2011?
Your answer should be very brief. 1.1. What is the ratio of the Rating (1=low 6=high) in East Asia (all income levels) in 2009 to that in 2012?
Make the answer very short. 1.03. What is the ratio of the Rating (1=low 6=high) of Pacific island small states in 2009 to that in 2012?
Make the answer very short. 1.11. What is the ratio of the Rating (1=low 6=high) of Mauritania in 2009 to that in 2012?
Your answer should be compact. 0.88. What is the ratio of the Rating (1=low 6=high) in Solomon Islands in 2009 to that in 2012?
Offer a terse response. 1. What is the ratio of the Rating (1=low 6=high) of East Asia (all income levels) in 2009 to that in 2013?
Ensure brevity in your answer.  1.06. What is the ratio of the Rating (1=low 6=high) in Pacific island small states in 2009 to that in 2013?
Provide a succinct answer. 1.11. What is the ratio of the Rating (1=low 6=high) of Solomon Islands in 2009 to that in 2013?
Give a very brief answer. 1. What is the ratio of the Rating (1=low 6=high) in East Asia (all income levels) in 2009 to that in 2014?
Ensure brevity in your answer.  1.06. What is the ratio of the Rating (1=low 6=high) in Pacific island small states in 2009 to that in 2014?
Ensure brevity in your answer.  1.11. What is the ratio of the Rating (1=low 6=high) of East Asia (all income levels) in 2010 to that in 2011?
Provide a short and direct response. 1.05. What is the ratio of the Rating (1=low 6=high) in Pacific island small states in 2010 to that in 2011?
Offer a terse response. 1.13. What is the ratio of the Rating (1=low 6=high) in East Asia (all income levels) in 2010 to that in 2012?
Your answer should be very brief. 1.06. What is the ratio of the Rating (1=low 6=high) of Pacific island small states in 2010 to that in 2012?
Make the answer very short. 1.14. What is the ratio of the Rating (1=low 6=high) in Mauritania in 2010 to that in 2012?
Your answer should be compact. 0.88. What is the ratio of the Rating (1=low 6=high) of Solomon Islands in 2010 to that in 2012?
Your answer should be very brief. 1. What is the ratio of the Rating (1=low 6=high) of East Asia (all income levels) in 2010 to that in 2013?
Your answer should be very brief. 1.1. What is the ratio of the Rating (1=low 6=high) in Pacific island small states in 2010 to that in 2013?
Make the answer very short. 1.14. What is the ratio of the Rating (1=low 6=high) in Mauritania in 2010 to that in 2013?
Provide a succinct answer. 0.88. What is the ratio of the Rating (1=low 6=high) in Solomon Islands in 2010 to that in 2013?
Your answer should be very brief. 1. What is the ratio of the Rating (1=low 6=high) of East Asia (all income levels) in 2010 to that in 2014?
Your response must be concise. 1.1. What is the ratio of the Rating (1=low 6=high) of Pacific island small states in 2010 to that in 2014?
Offer a very short reply. 1.14. What is the ratio of the Rating (1=low 6=high) of Mauritania in 2010 to that in 2014?
Make the answer very short. 0.88. What is the ratio of the Rating (1=low 6=high) of East Asia (all income levels) in 2011 to that in 2012?
Give a very brief answer. 1.01. What is the ratio of the Rating (1=low 6=high) of Mauritania in 2011 to that in 2012?
Provide a succinct answer. 0.88. What is the ratio of the Rating (1=low 6=high) in East Asia (all income levels) in 2011 to that in 2013?
Offer a very short reply. 1.04. What is the ratio of the Rating (1=low 6=high) in Mauritania in 2011 to that in 2013?
Your response must be concise. 0.88. What is the ratio of the Rating (1=low 6=high) in East Asia (all income levels) in 2011 to that in 2014?
Make the answer very short. 1.04. What is the ratio of the Rating (1=low 6=high) in Pacific island small states in 2011 to that in 2014?
Offer a very short reply. 1.01. What is the ratio of the Rating (1=low 6=high) of East Asia (all income levels) in 2012 to that in 2013?
Ensure brevity in your answer.  1.03. What is the ratio of the Rating (1=low 6=high) of Mauritania in 2012 to that in 2013?
Provide a succinct answer. 1. What is the ratio of the Rating (1=low 6=high) in East Asia (all income levels) in 2012 to that in 2014?
Your answer should be compact. 1.03. What is the ratio of the Rating (1=low 6=high) in Pacific island small states in 2012 to that in 2014?
Offer a very short reply. 1. What is the ratio of the Rating (1=low 6=high) of Solomon Islands in 2012 to that in 2014?
Make the answer very short. 1. What is the ratio of the Rating (1=low 6=high) of East Asia (all income levels) in 2013 to that in 2014?
Provide a short and direct response. 1. What is the ratio of the Rating (1=low 6=high) in Pacific island small states in 2013 to that in 2014?
Provide a succinct answer. 1. What is the difference between the highest and the second highest Rating (1=low 6=high) in East Asia (all income levels)?
Your response must be concise. 0.14. What is the difference between the highest and the second highest Rating (1=low 6=high) of Pacific island small states?
Make the answer very short. 0.1. What is the difference between the highest and the second highest Rating (1=low 6=high) of Mauritania?
Offer a terse response. 0. What is the difference between the highest and the lowest Rating (1=low 6=high) of East Asia (all income levels)?
Your response must be concise. 0.33. What is the difference between the highest and the lowest Rating (1=low 6=high) of Pacific island small states?
Offer a very short reply. 0.45. What is the difference between the highest and the lowest Rating (1=low 6=high) in Solomon Islands?
Offer a terse response. 0. 